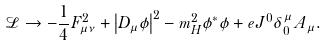<formula> <loc_0><loc_0><loc_500><loc_500>\mathcal { L } \to - \frac { 1 } { 4 } F _ { \mu \nu } ^ { 2 } + \left | { D _ { \mu } \phi } \right | ^ { 2 } - m _ { H } ^ { 2 } \phi ^ { * } \phi + e J ^ { 0 } \delta ^ { \mu } _ { 0 } \, A _ { \mu } .</formula> 